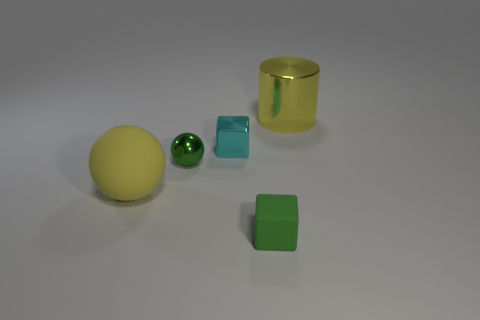How many big objects are the same color as the large metallic cylinder?
Make the answer very short. 1. How many matte objects are left of the metallic block and to the right of the small sphere?
Offer a very short reply. 0. The metal thing that is the same size as the yellow matte object is what shape?
Your response must be concise. Cylinder. The cyan metal thing is what size?
Your response must be concise. Small. The green thing that is in front of the large yellow object that is in front of the yellow thing to the right of the tiny matte thing is made of what material?
Offer a terse response. Rubber. There is a tiny block that is the same material as the big yellow cylinder; what is its color?
Your answer should be very brief. Cyan. There is a rubber thing right of the object on the left side of the small green sphere; how many large yellow balls are left of it?
Your answer should be very brief. 1. What material is the cylinder that is the same color as the large ball?
Provide a short and direct response. Metal. Are there any other things that are the same shape as the green metallic thing?
Offer a terse response. Yes. How many things are green objects to the right of the tiny cyan shiny object or big green matte things?
Your answer should be compact. 1. 